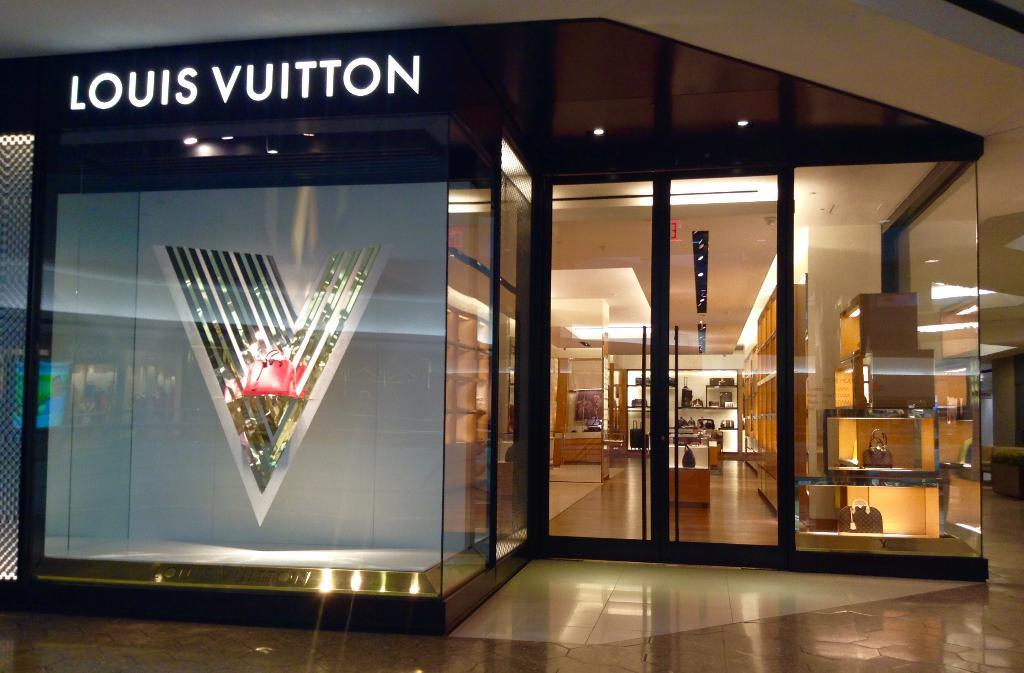<image>
Share a concise interpretation of the image provided. A Louis Vuitton store with glass windows and doors. 